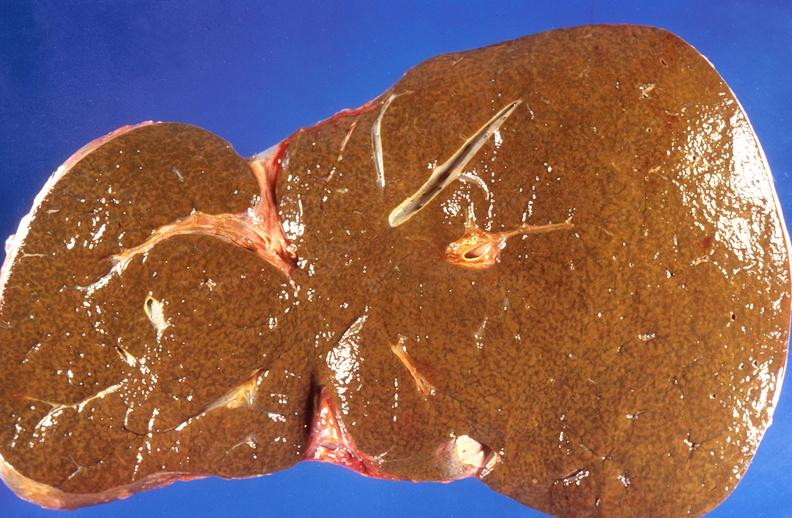what does this image show?
Answer the question using a single word or phrase. Liver 